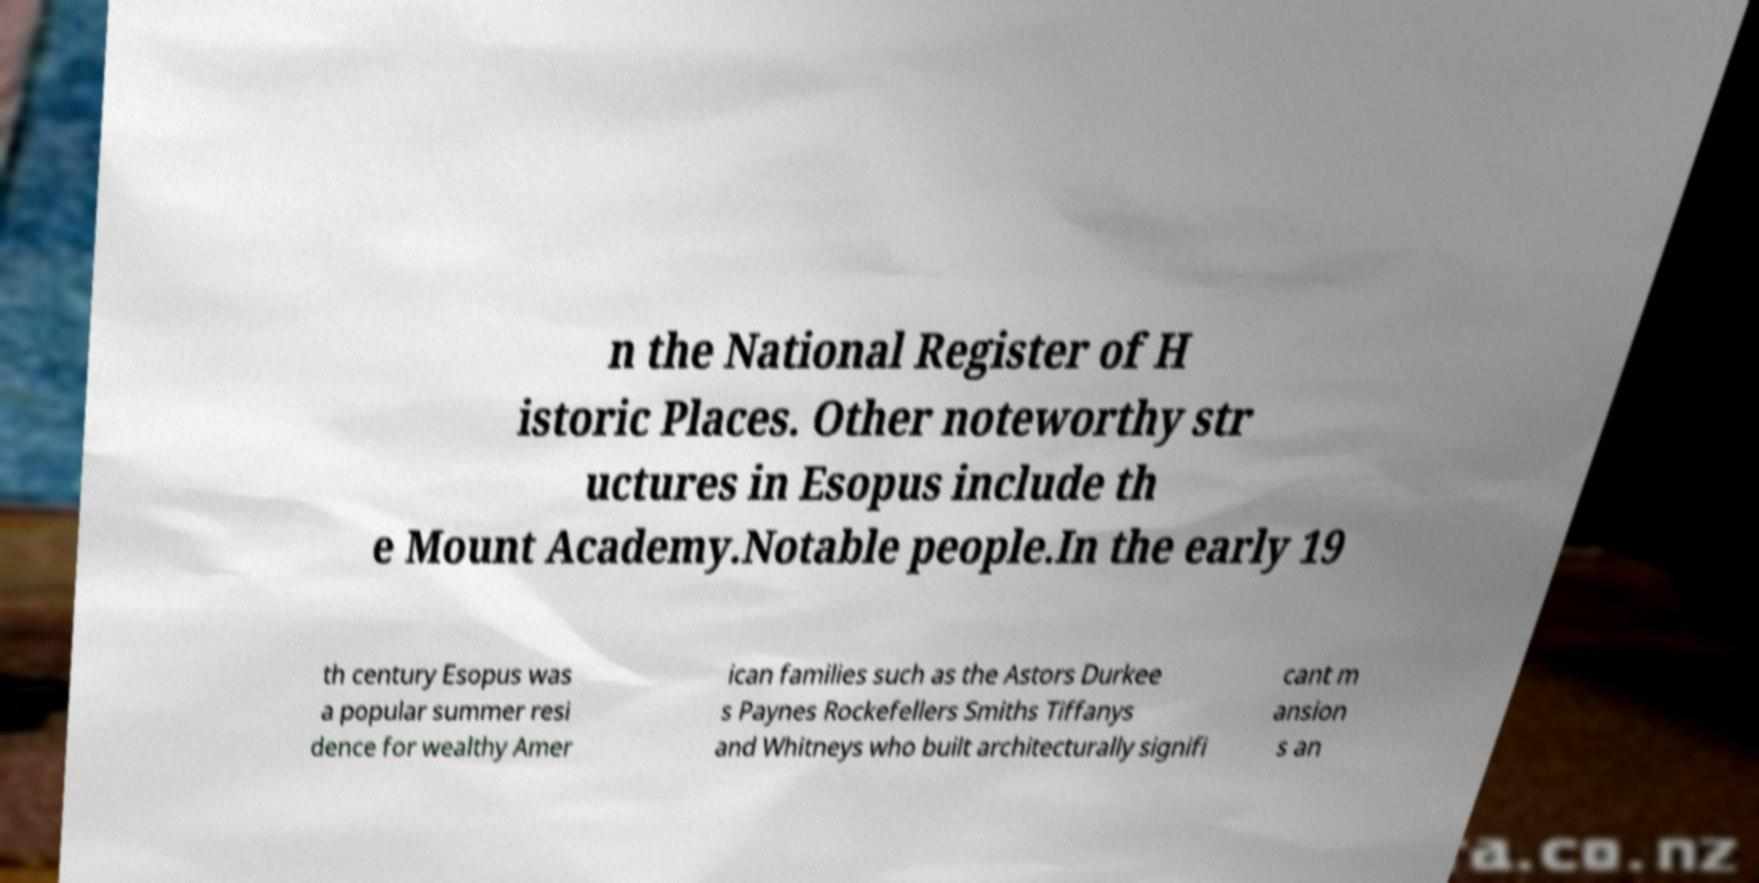Can you read and provide the text displayed in the image?This photo seems to have some interesting text. Can you extract and type it out for me? n the National Register of H istoric Places. Other noteworthy str uctures in Esopus include th e Mount Academy.Notable people.In the early 19 th century Esopus was a popular summer resi dence for wealthy Amer ican families such as the Astors Durkee s Paynes Rockefellers Smiths Tiffanys and Whitneys who built architecturally signifi cant m ansion s an 